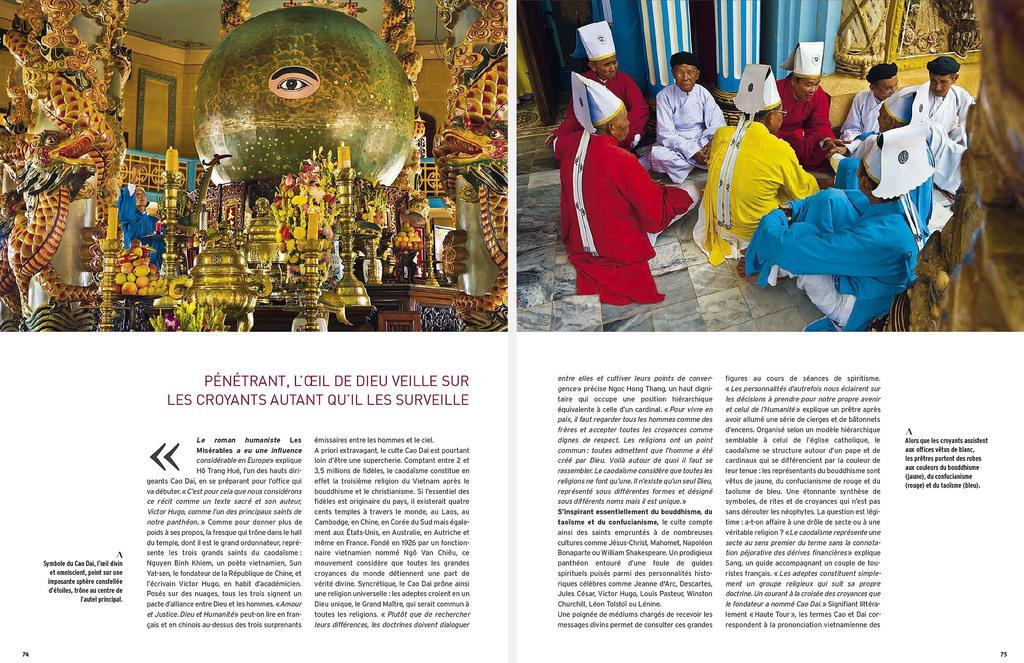How many pictures can be seen in the image? There are two pictures in the image. What else is present in the image besides the pictures? There is text visible in the image. How many children are swimming in the spring depicted in the image? There is no depiction of children swimming in a spring in the image. 